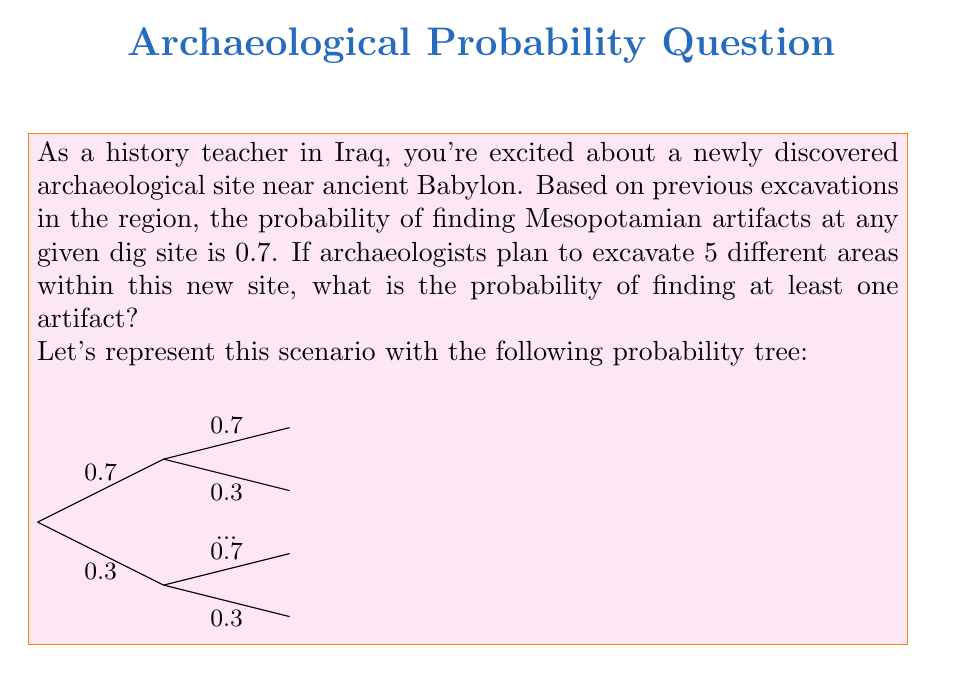Could you help me with this problem? Let's approach this step-by-step using Bayesian probability:

1) First, let's consider the probability of not finding an artifact in a single area:
   $P(\text{no artifact}) = 1 - P(\text{artifact}) = 1 - 0.7 = 0.3$

2) For 5 different areas, the probability of finding no artifacts in any of them is:
   $P(\text{no artifacts in 5 areas}) = 0.3^5$

3) Therefore, the probability of finding at least one artifact is the complement of finding no artifacts:
   $P(\text{at least one artifact}) = 1 - P(\text{no artifacts in 5 areas})$

4) Let's calculate:
   $P(\text{at least one artifact}) = 1 - 0.3^5$
   $= 1 - 0.00243$
   $= 0.99757$

5) Converting to a percentage:
   $0.99757 \times 100\% = 99.757\%$

This high probability reflects the rich archaeological heritage of the Mesopotamian region, which is a source of pride for many Iraqis.
Answer: $99.757\%$ 